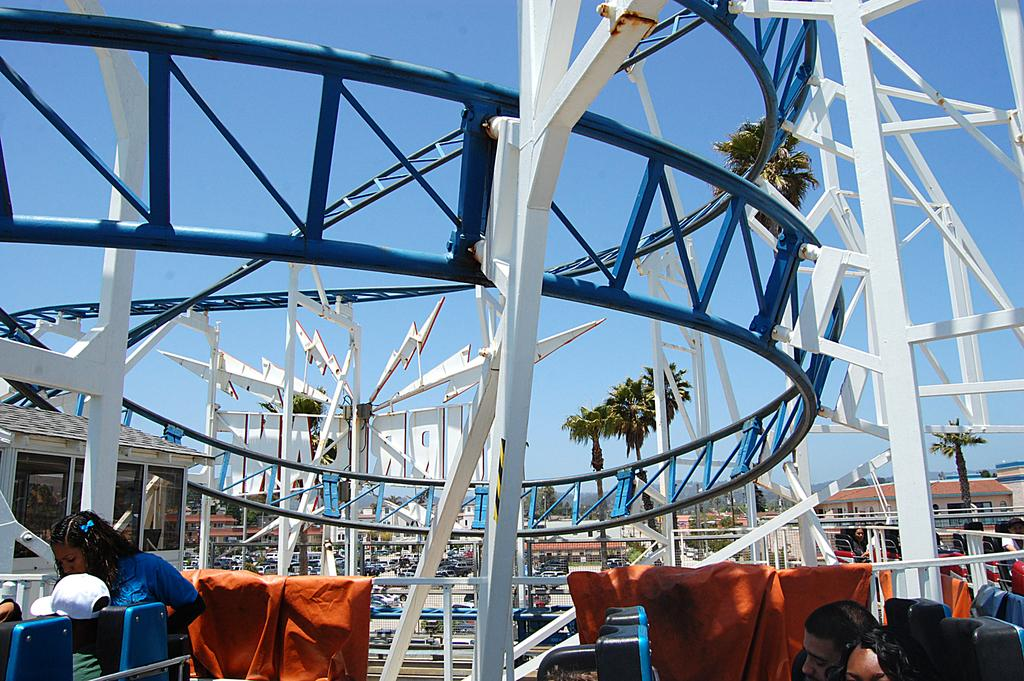Who or what can be seen in the image? There are people in the image. What type of structure is present in the image? There is a roller coaster in the image. What material are some of the objects made of in the image? There are metallic objects in the image. What is the ground like in the image? The ground is visible in the image. What type of vegetation is present in the image? There are trees in the image. What type of man-made structures can be seen in the image? There are buildings in the image. What part of the natural environment is visible in the image? The sky is visible in the image. What type of pain can be seen on the faces of the people in the image? There is no indication of pain on the faces of the people in the image. How does the record player push the music in the image? There is no record player present in the image. 